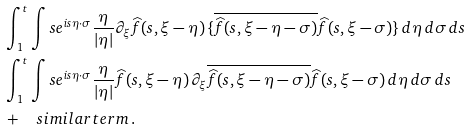<formula> <loc_0><loc_0><loc_500><loc_500>& \int _ { 1 } ^ { t } \int s e ^ { i s \eta \cdot \sigma } \frac { \eta } { | \eta | } \partial _ { \xi } \widehat { f } ( s , \xi - \eta ) \, \{ \overline { \widehat { f } ( s , \xi - \eta - \sigma ) } \widehat { f } ( s , \xi - \sigma ) \} \, d \eta \, d \sigma \, d s \\ & \int _ { 1 } ^ { t } \int s e ^ { i s \eta \cdot \sigma } \frac { \eta } { | \eta | } \widehat { f } ( s , \xi - \eta ) \, \partial _ { \xi } \overline { \widehat { f } ( s , \xi - \eta - \sigma ) } \widehat { f } ( s , \xi - \sigma ) \, d \eta \, d \sigma \, d s \\ & + \quad s i m i l a r t e r m \, .</formula> 